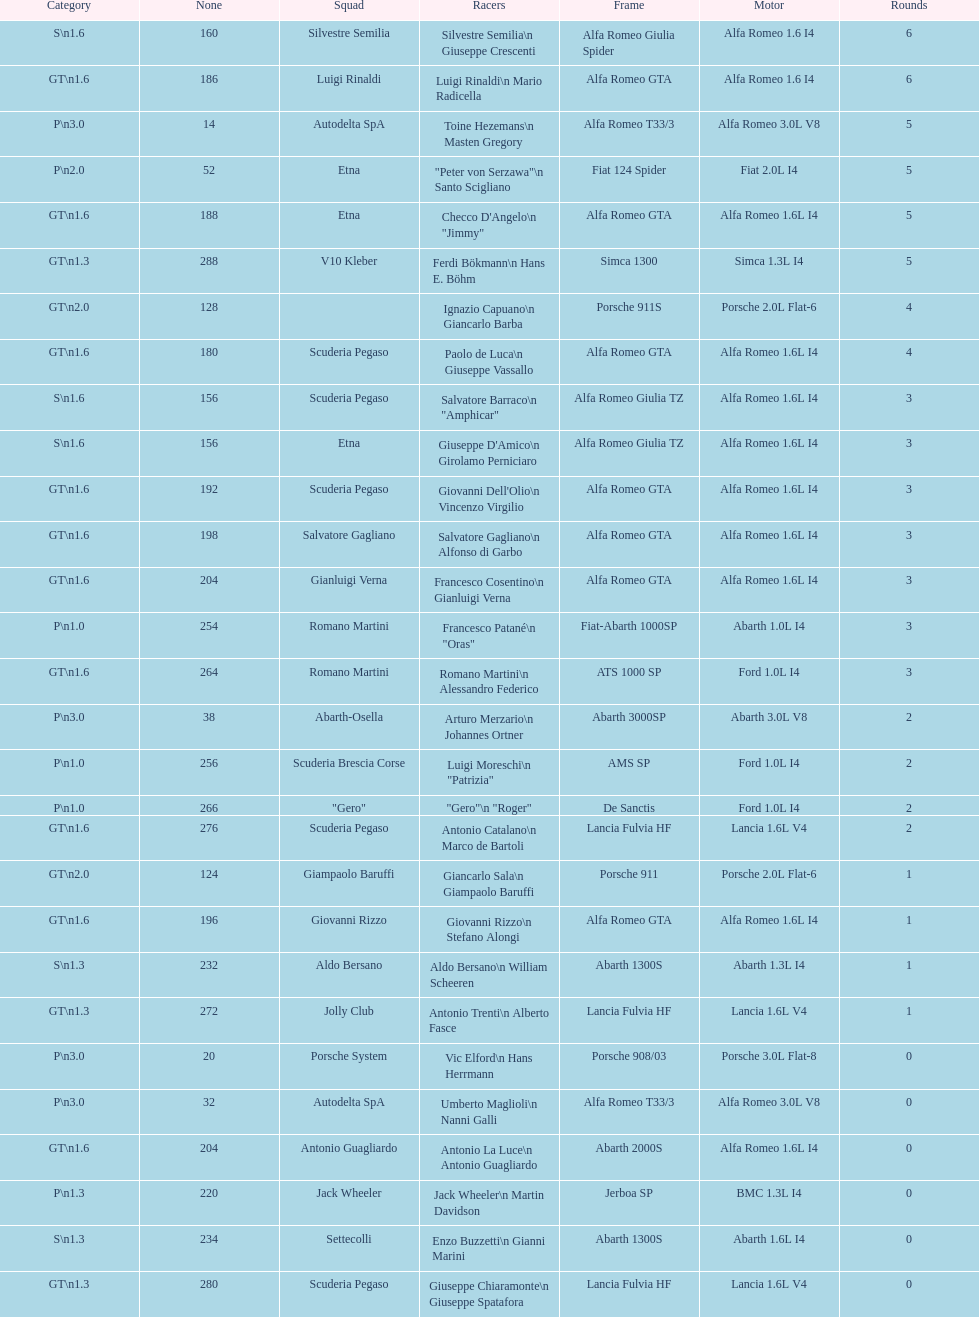How many drivers are from italy? 48. 